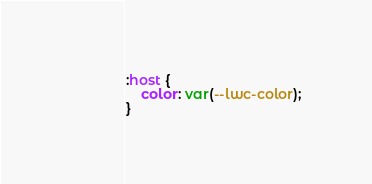<code> <loc_0><loc_0><loc_500><loc_500><_CSS_>:host {
	color: var(--lwc-color);
}</code> 